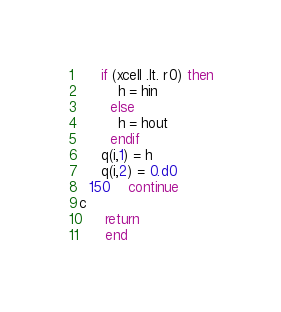Convert code to text. <code><loc_0><loc_0><loc_500><loc_500><_FORTRAN_>	 if (xcell .lt. r0) then
	     h = hin
	   else
	     h = hout
	   endif
	 q(i,1) = h
	 q(i,2) = 0.d0
  150    continue
c
      return
      end
</code> 